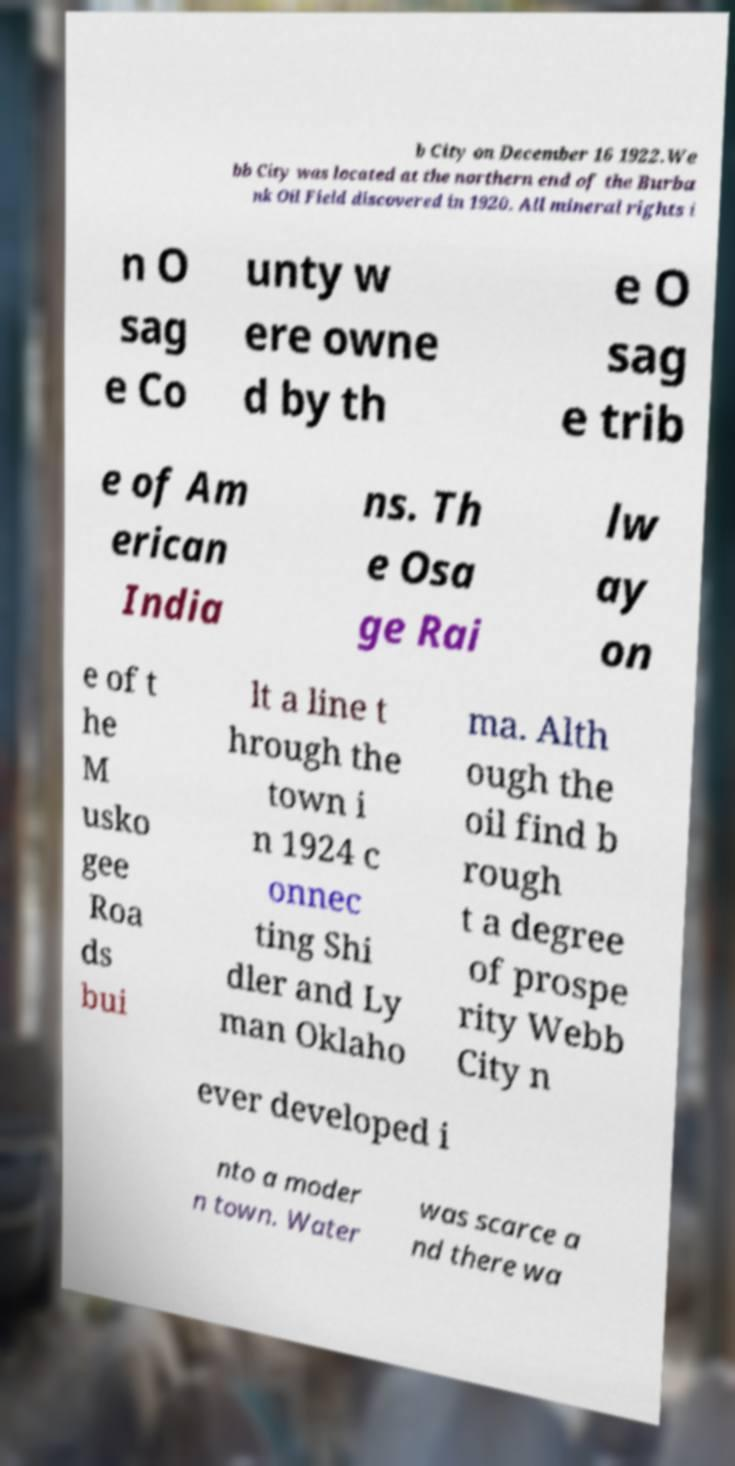There's text embedded in this image that I need extracted. Can you transcribe it verbatim? b City on December 16 1922.We bb City was located at the northern end of the Burba nk Oil Field discovered in 1920. All mineral rights i n O sag e Co unty w ere owne d by th e O sag e trib e of Am erican India ns. Th e Osa ge Rai lw ay on e of t he M usko gee Roa ds bui lt a line t hrough the town i n 1924 c onnec ting Shi dler and Ly man Oklaho ma. Alth ough the oil find b rough t a degree of prospe rity Webb City n ever developed i nto a moder n town. Water was scarce a nd there wa 